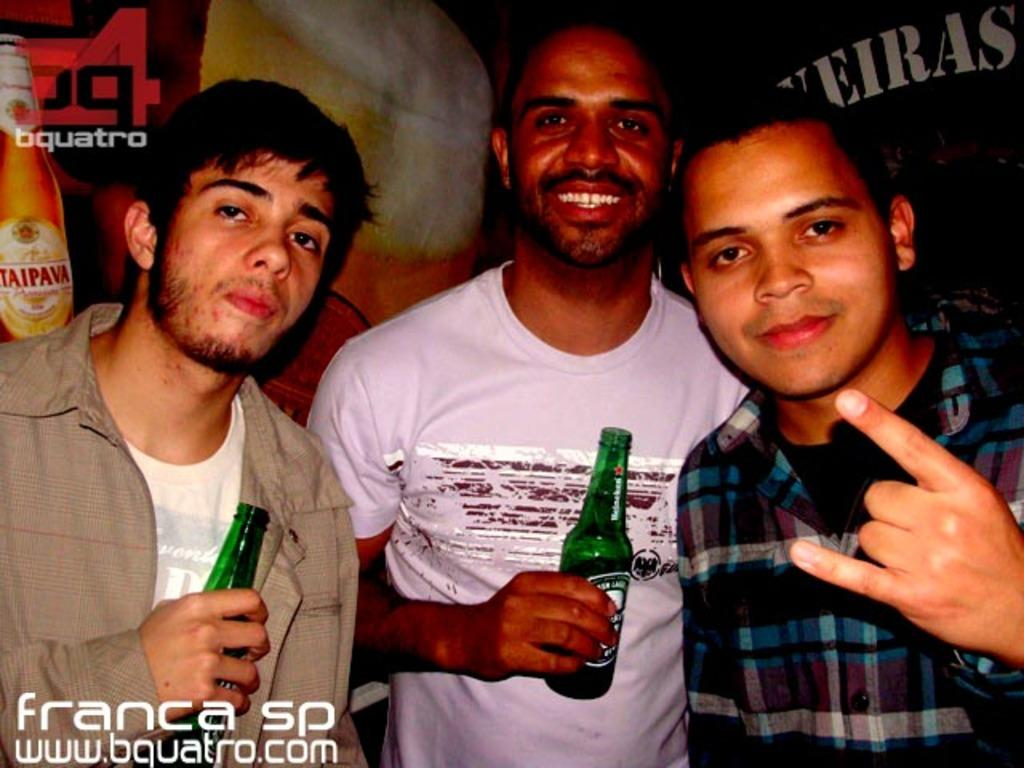How many people are present in the image? There are three people standing in the image. What are the two people on the left side holding in their hands? They are holding green color glass bottles in their hands. What type of toothbrush can be seen in the image? There is no toothbrush present in the image. Is there a plane visible in the image? There is no plane visible in the image. 